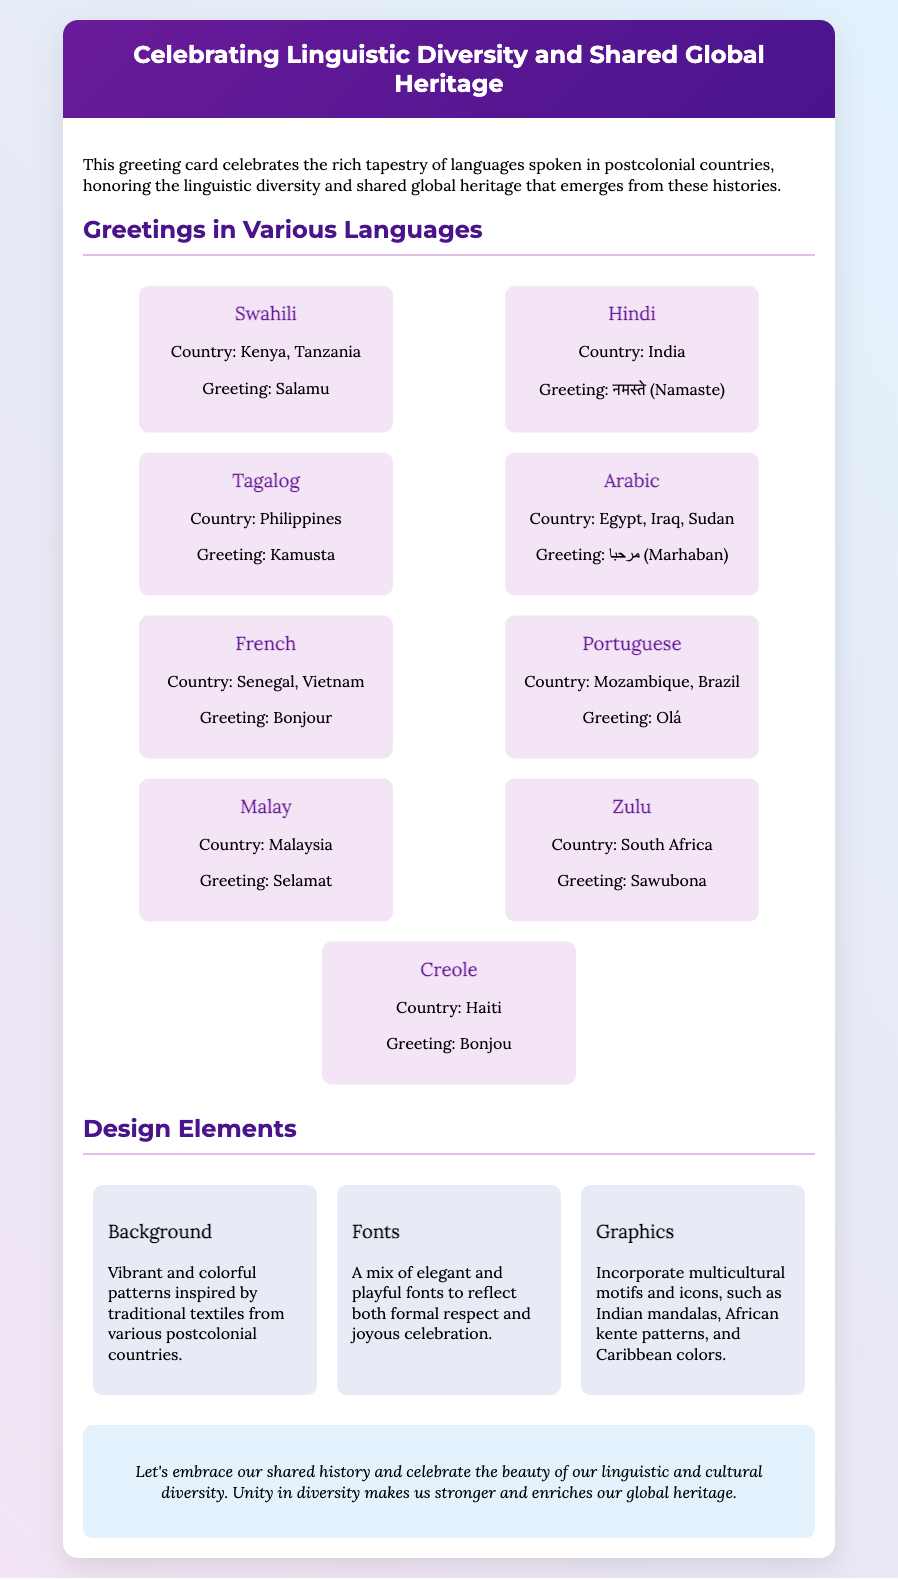What is the main theme of the card? The theme of the card celebrates linguistic diversity and shared global heritage in postcolonial countries.
Answer: Linguistic diversity and shared global heritage How many greetings are listed in the card? There are a total of nine greetings presented for different languages.
Answer: Nine What is the Swahili greeting featured? The Swahili greeting included in the card is "Salamu".
Answer: Salamu Which countries are mentioned with the Arabic greeting? The card specifies Egypt, Iraq, and Sudan as the countries associated with the Arabic greeting.
Answer: Egypt, Iraq, Sudan What design elements are included in the card? The card includes background patterns, fonts, and graphics as design elements.
Answer: Background, fonts, graphics Which language's greeting is "Nnamaste"? The greeting "नमस्ते" (Namaste) is from the Hindi language.
Answer: Hindi What colors are associated with the background design? The background design features vibrant and colorful patterns inspired by traditional textiles.
Answer: Vibrant and colorful patterns What message does the card convey at the end? The concluding message emphasizes embracing shared history and celebrating diversity.
Answer: Embrace shared history and celebrate diversity 